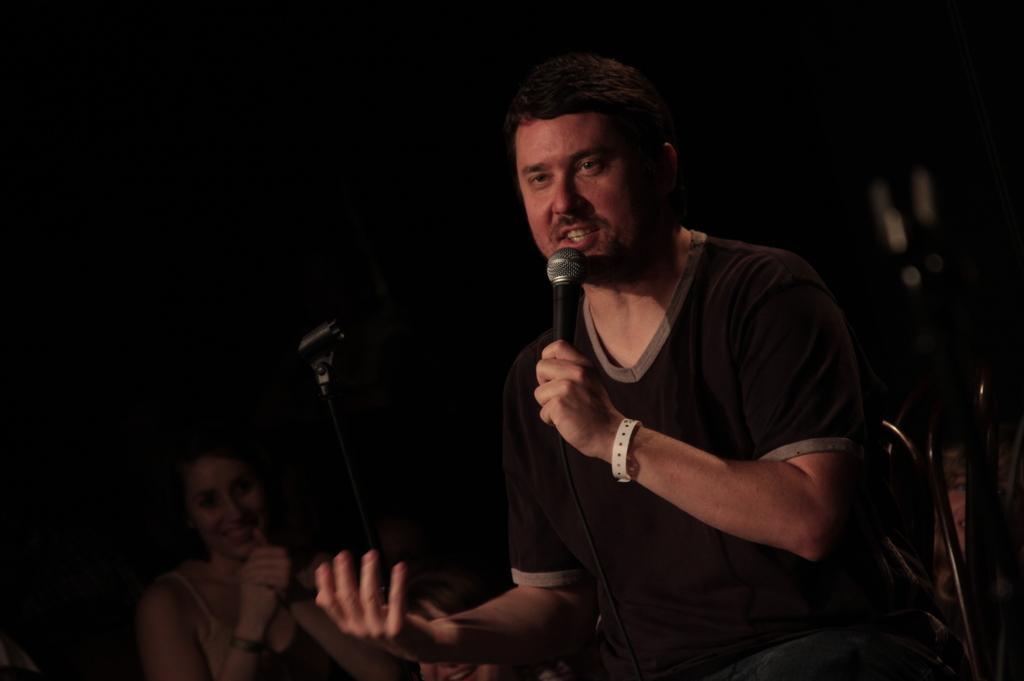Describe this image in one or two sentences. In this picture we can see a man who is holding a mike with his hand. Here we can see a woman. 